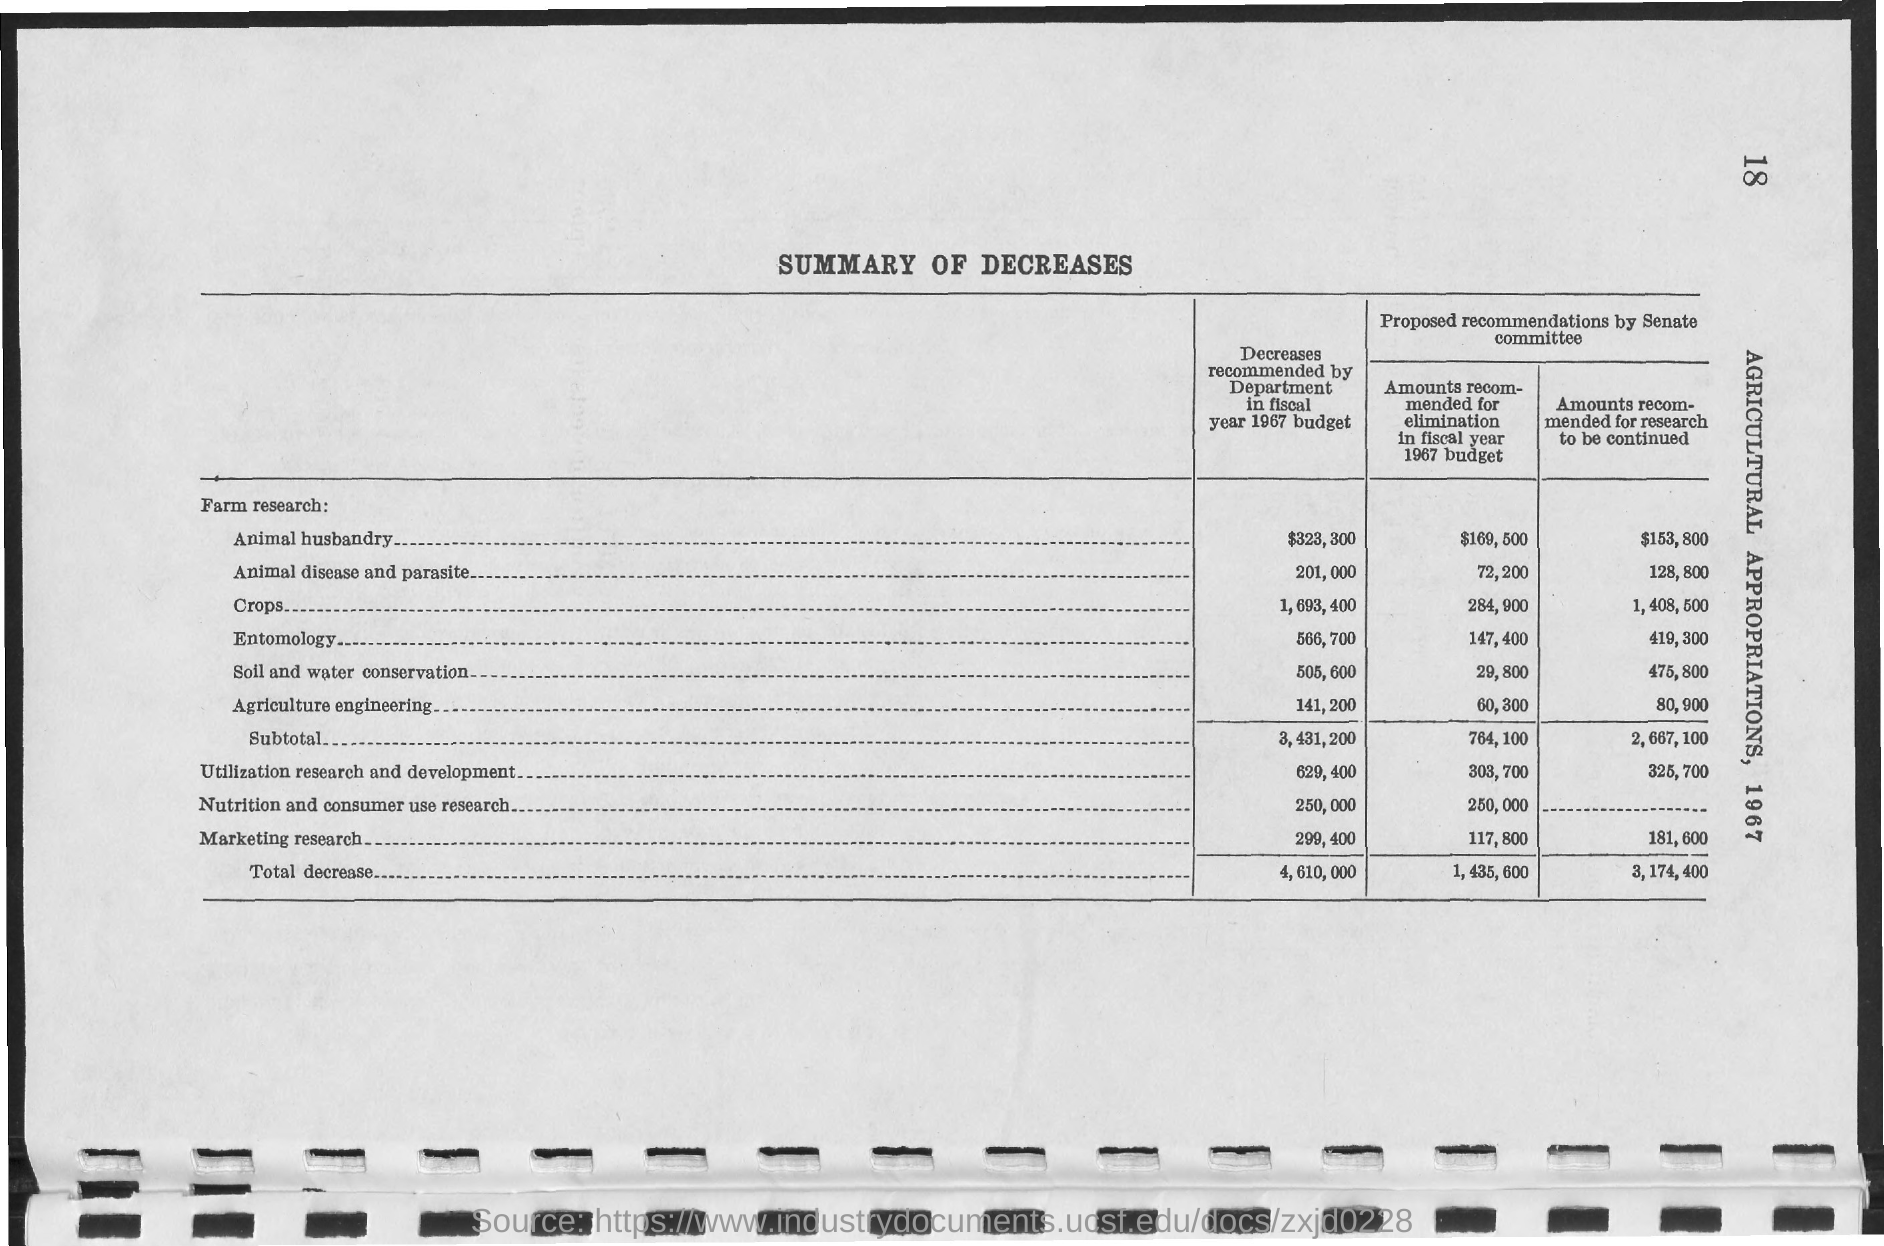What is the Page Number?
Offer a very short reply. 18. What is the title of the document?
Provide a succinct answer. SUMMARY OF DECREASES. 